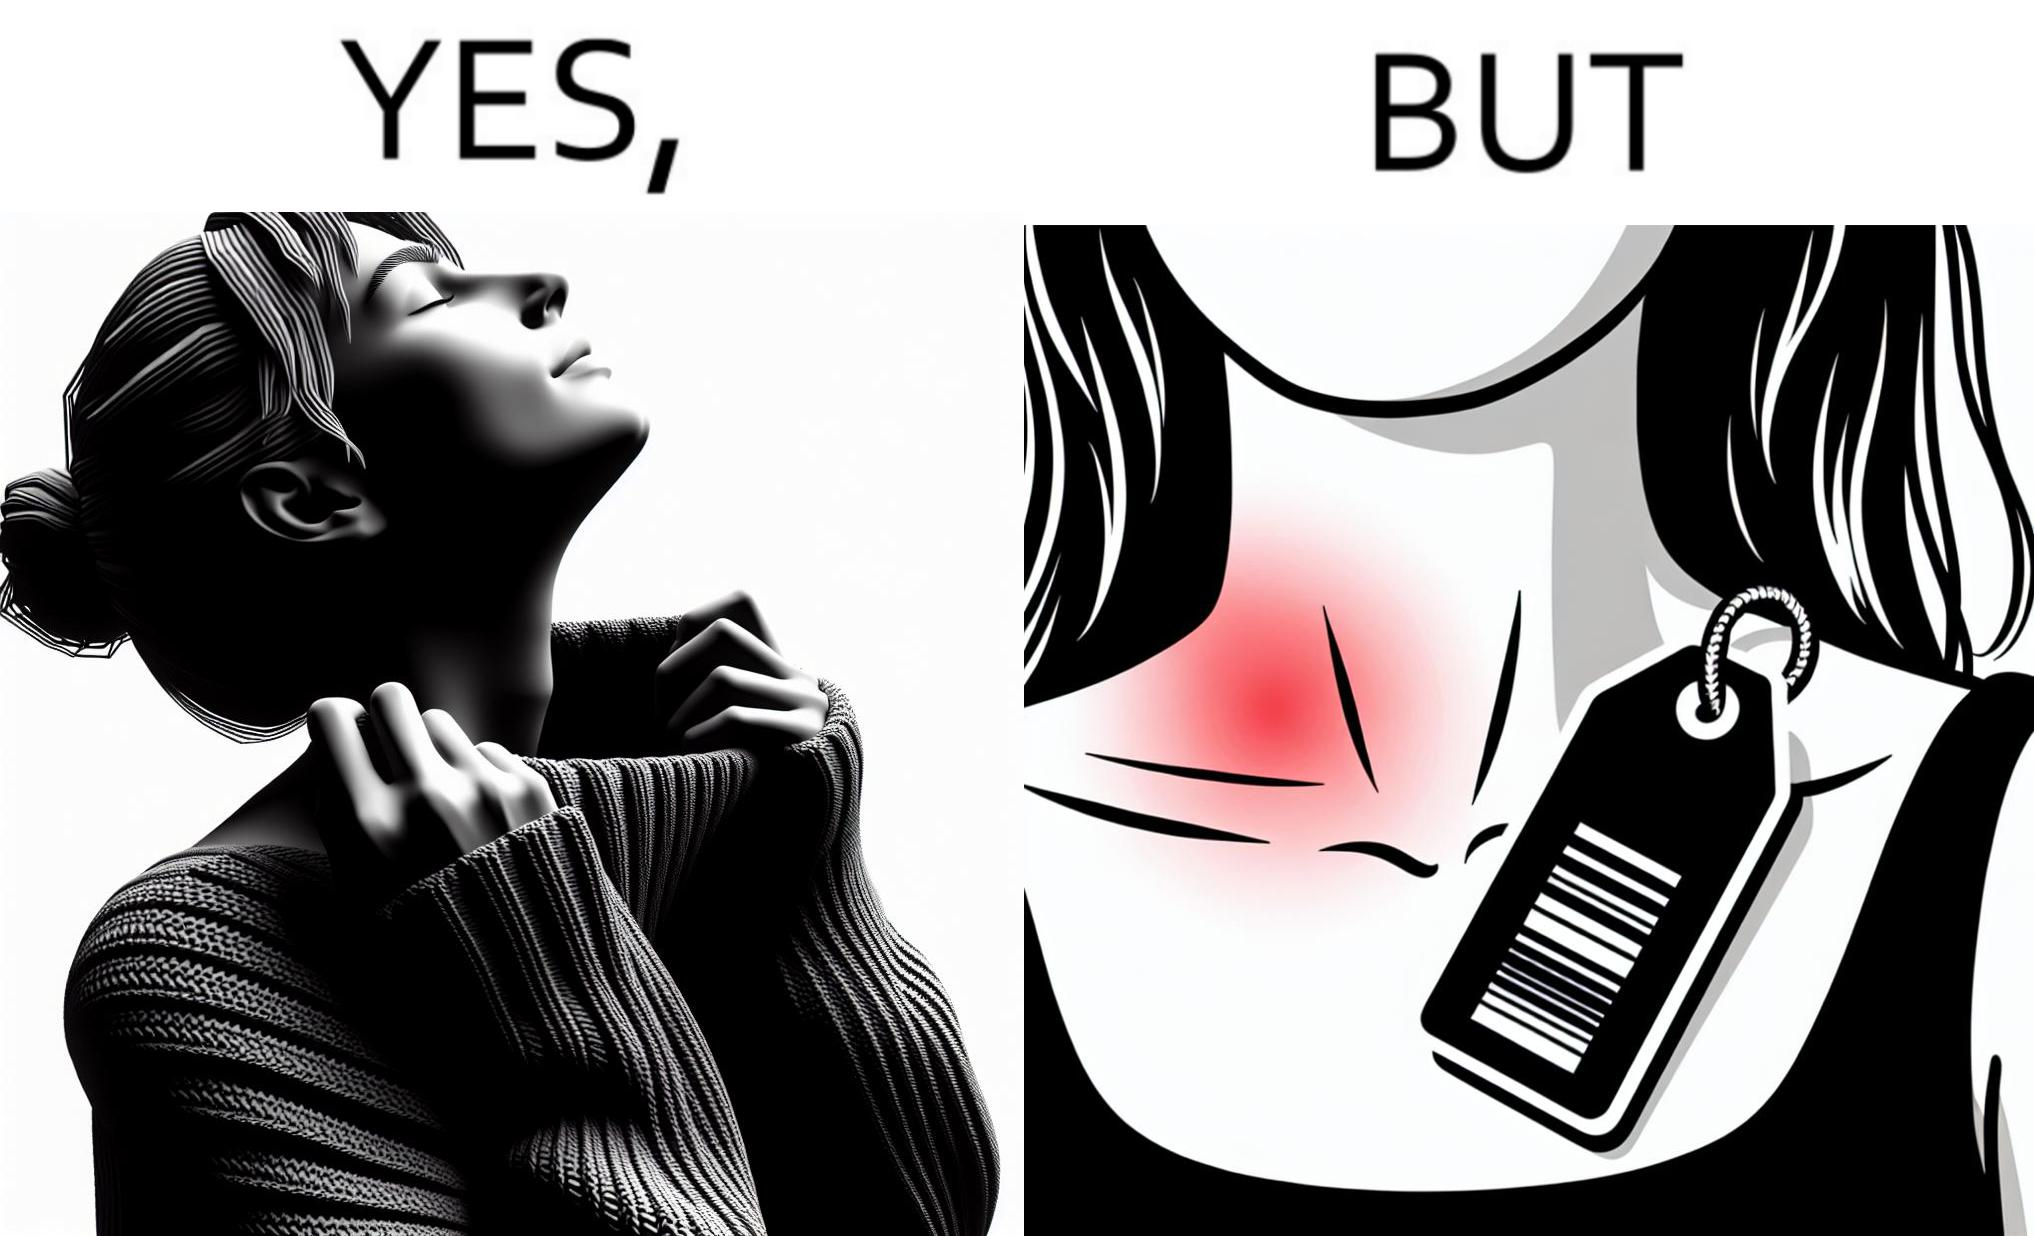Is this image satirical or non-satirical? Yes, this image is satirical. 